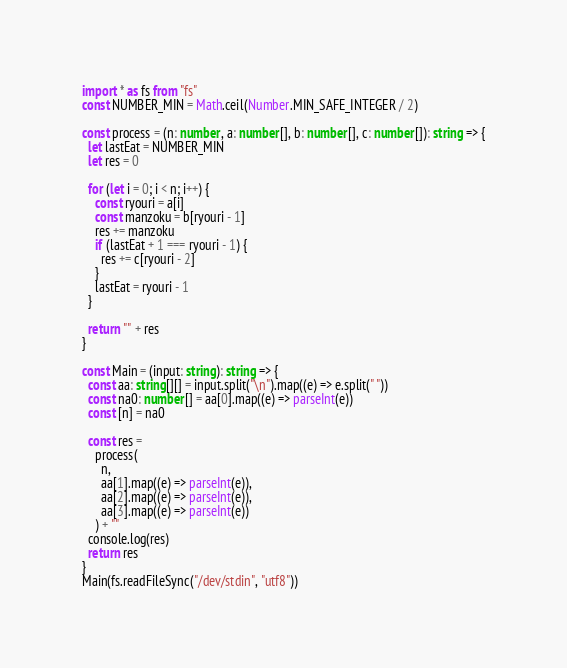Convert code to text. <code><loc_0><loc_0><loc_500><loc_500><_TypeScript_>import * as fs from "fs"
const NUMBER_MIN = Math.ceil(Number.MIN_SAFE_INTEGER / 2)

const process = (n: number, a: number[], b: number[], c: number[]): string => {
  let lastEat = NUMBER_MIN
  let res = 0

  for (let i = 0; i < n; i++) {
    const ryouri = a[i]
    const manzoku = b[ryouri - 1]
    res += manzoku
    if (lastEat + 1 === ryouri - 1) {
      res += c[ryouri - 2]
    }
    lastEat = ryouri - 1
  }

  return "" + res
}

const Main = (input: string): string => {
  const aa: string[][] = input.split("\n").map((e) => e.split(" "))
  const na0: number[] = aa[0].map((e) => parseInt(e))
  const [n] = na0

  const res =
    process(
      n,
      aa[1].map((e) => parseInt(e)),
      aa[2].map((e) => parseInt(e)),
      aa[3].map((e) => parseInt(e))
    ) + ""
  console.log(res)
  return res
}
Main(fs.readFileSync("/dev/stdin", "utf8"))
</code> 